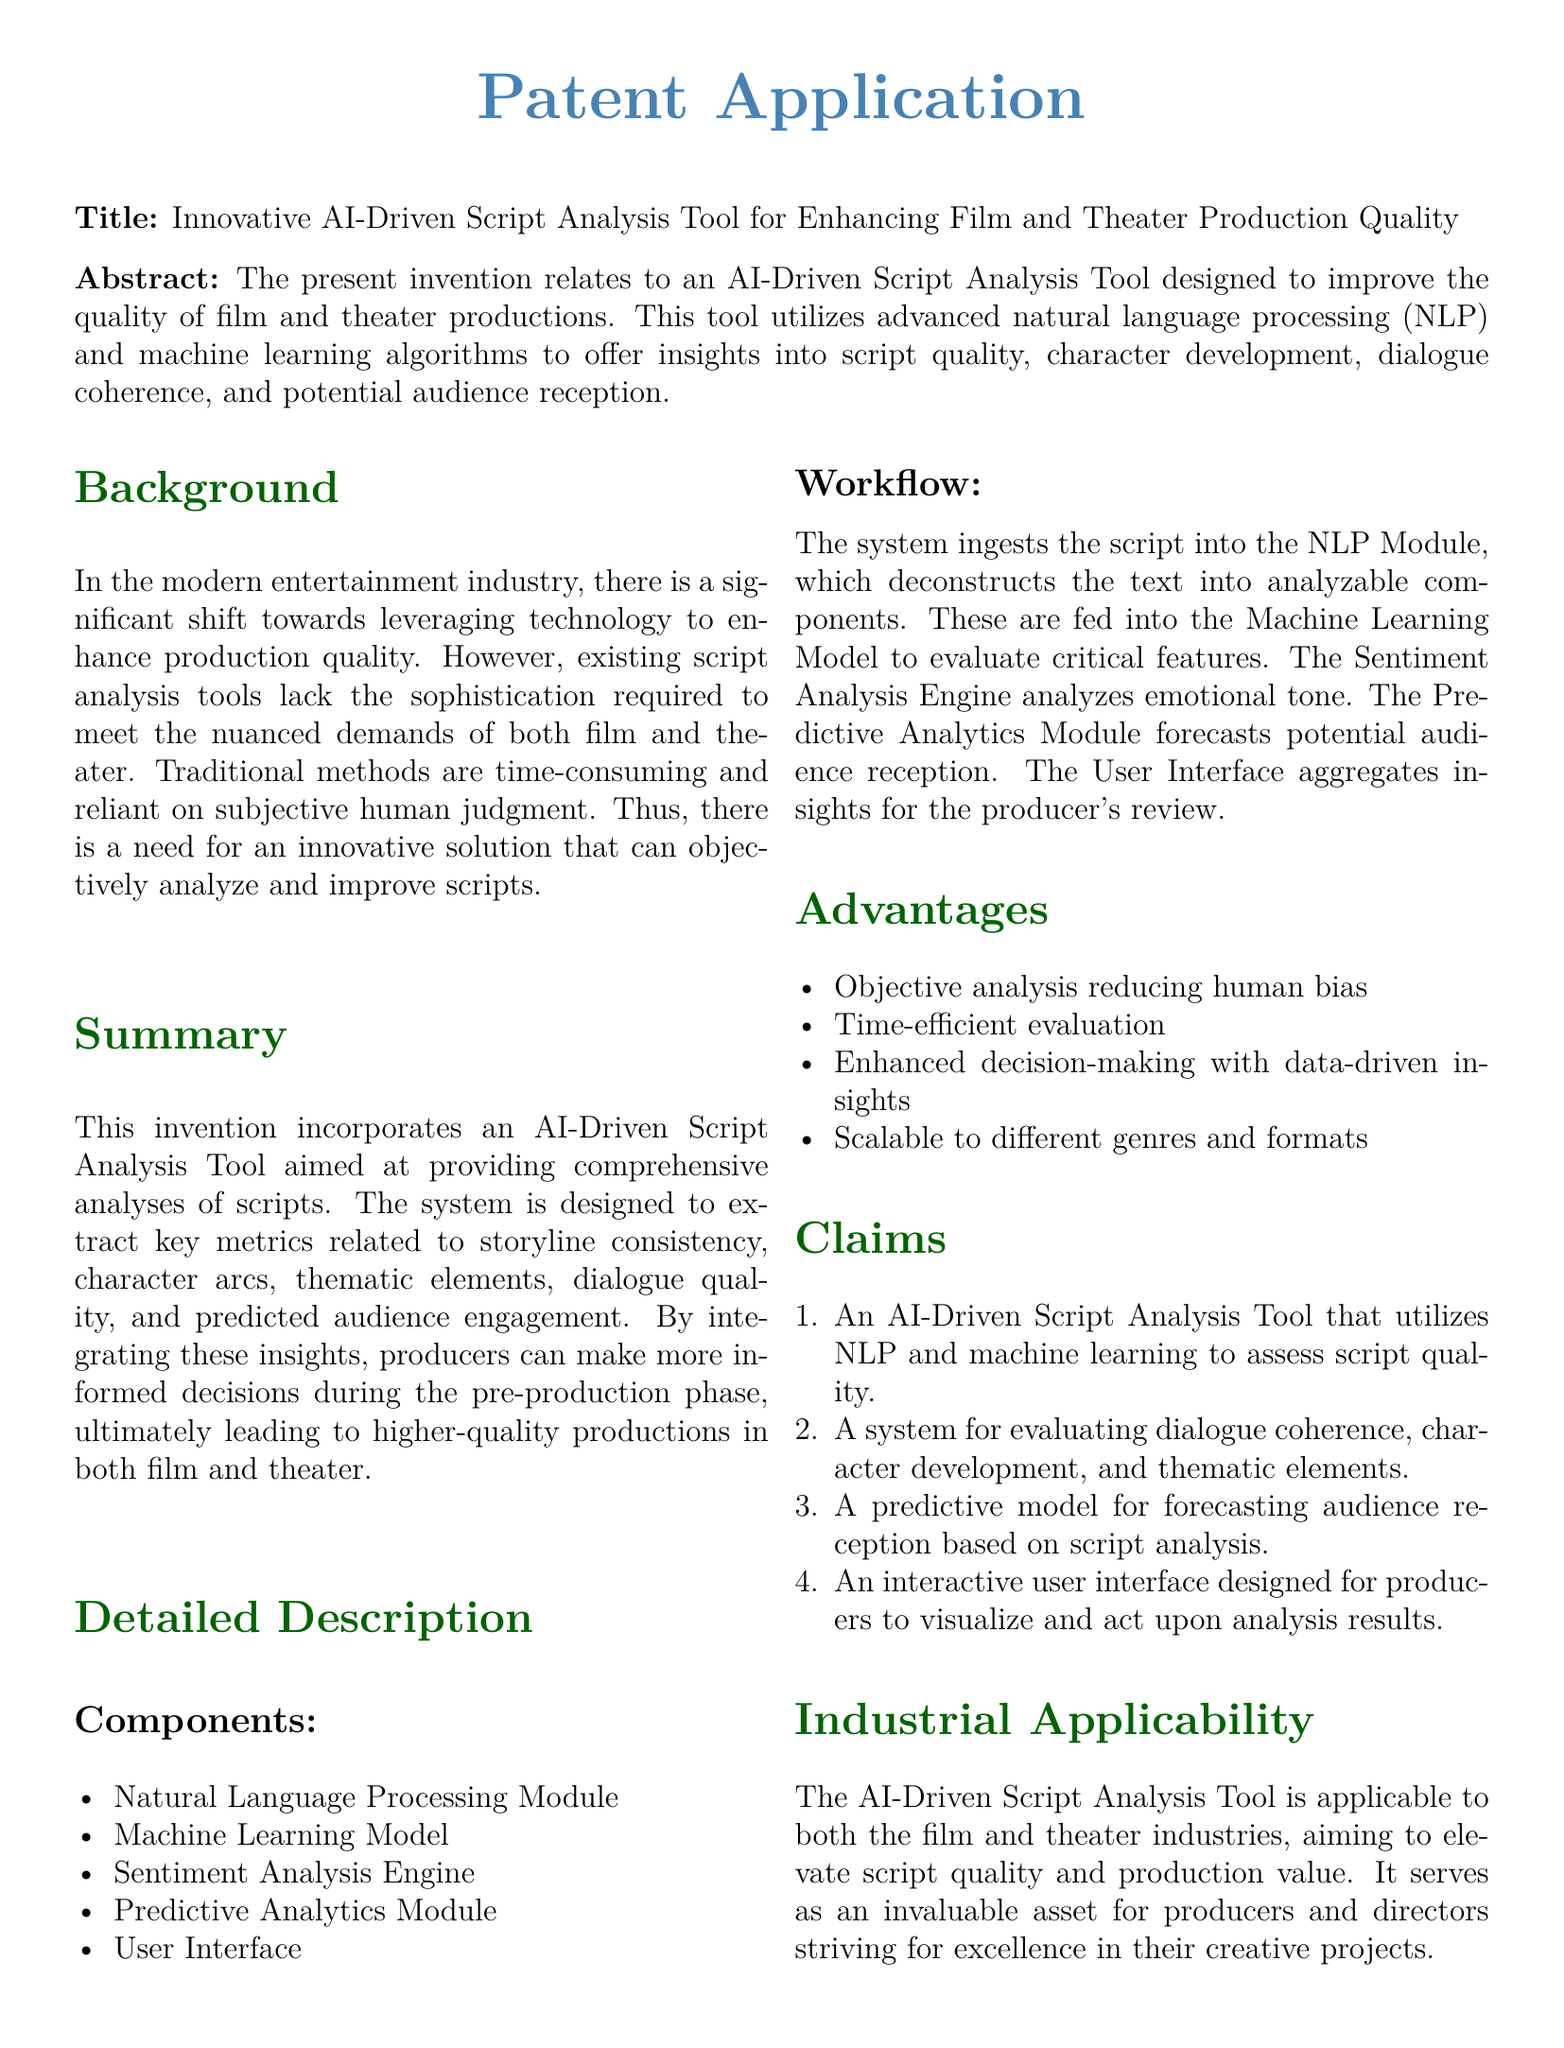What is the title of the invention? The title of the invention is prominently stated in the document's title section.
Answer: Innovative AI-Driven Script Analysis Tool for Enhancing Film and Theater Production Quality What technology does the tool utilize for analysis? The document specifically mentions two technologies that the tool employs.
Answer: Natural language processing and machine learning What module analyzes emotional tone? The document designates a specific component that performs this analysis.
Answer: Sentiment Analysis Engine What does the Predictive Analytics Module forecast? The function of the Predictive Analytics Module is clearly outlined in the document.
Answer: Potential audience reception How many claims are made in the application? The number of claims is enumerated in the claims section of the document.
Answer: Four What is a key advantage mentioned for the tool? The document lists multiple advantages, highlighting a specific one in the advantages section.
Answer: Objective analysis reducing human bias In which industries is the tool applicable? The application specifies the main industries that would benefit from the tool.
Answer: Film and theater What does the User Interface aggregate? The User Interface's function is explicitly defined in the workflow section of the document.
Answer: Insights for the producer's review 